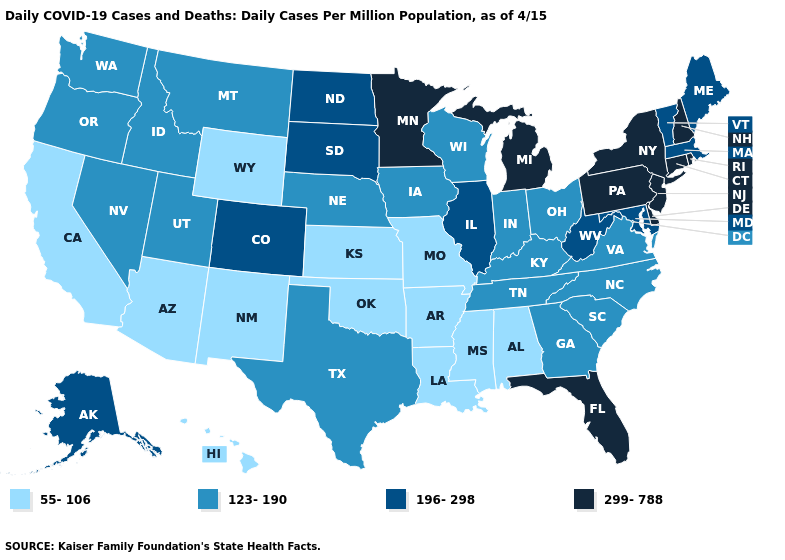What is the value of Kentucky?
Short answer required. 123-190. What is the value of Nebraska?
Keep it brief. 123-190. Does Georgia have the lowest value in the South?
Concise answer only. No. Name the states that have a value in the range 123-190?
Keep it brief. Georgia, Idaho, Indiana, Iowa, Kentucky, Montana, Nebraska, Nevada, North Carolina, Ohio, Oregon, South Carolina, Tennessee, Texas, Utah, Virginia, Washington, Wisconsin. Does Michigan have the highest value in the MidWest?
Give a very brief answer. Yes. What is the lowest value in the MidWest?
Write a very short answer. 55-106. What is the lowest value in the USA?
Answer briefly. 55-106. Which states have the lowest value in the West?
Answer briefly. Arizona, California, Hawaii, New Mexico, Wyoming. Name the states that have a value in the range 55-106?
Give a very brief answer. Alabama, Arizona, Arkansas, California, Hawaii, Kansas, Louisiana, Mississippi, Missouri, New Mexico, Oklahoma, Wyoming. Name the states that have a value in the range 196-298?
Short answer required. Alaska, Colorado, Illinois, Maine, Maryland, Massachusetts, North Dakota, South Dakota, Vermont, West Virginia. Which states have the lowest value in the West?
Answer briefly. Arizona, California, Hawaii, New Mexico, Wyoming. What is the value of South Carolina?
Quick response, please. 123-190. Does Utah have the same value as Iowa?
Keep it brief. Yes. Does the map have missing data?
Short answer required. No. What is the lowest value in the Northeast?
Give a very brief answer. 196-298. 